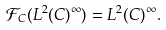Convert formula to latex. <formula><loc_0><loc_0><loc_500><loc_500>\mathcal { F } _ { C } ( L ^ { 2 } ( C ) ^ { \infty } ) = L ^ { 2 } ( C ) ^ { \infty } .</formula> 